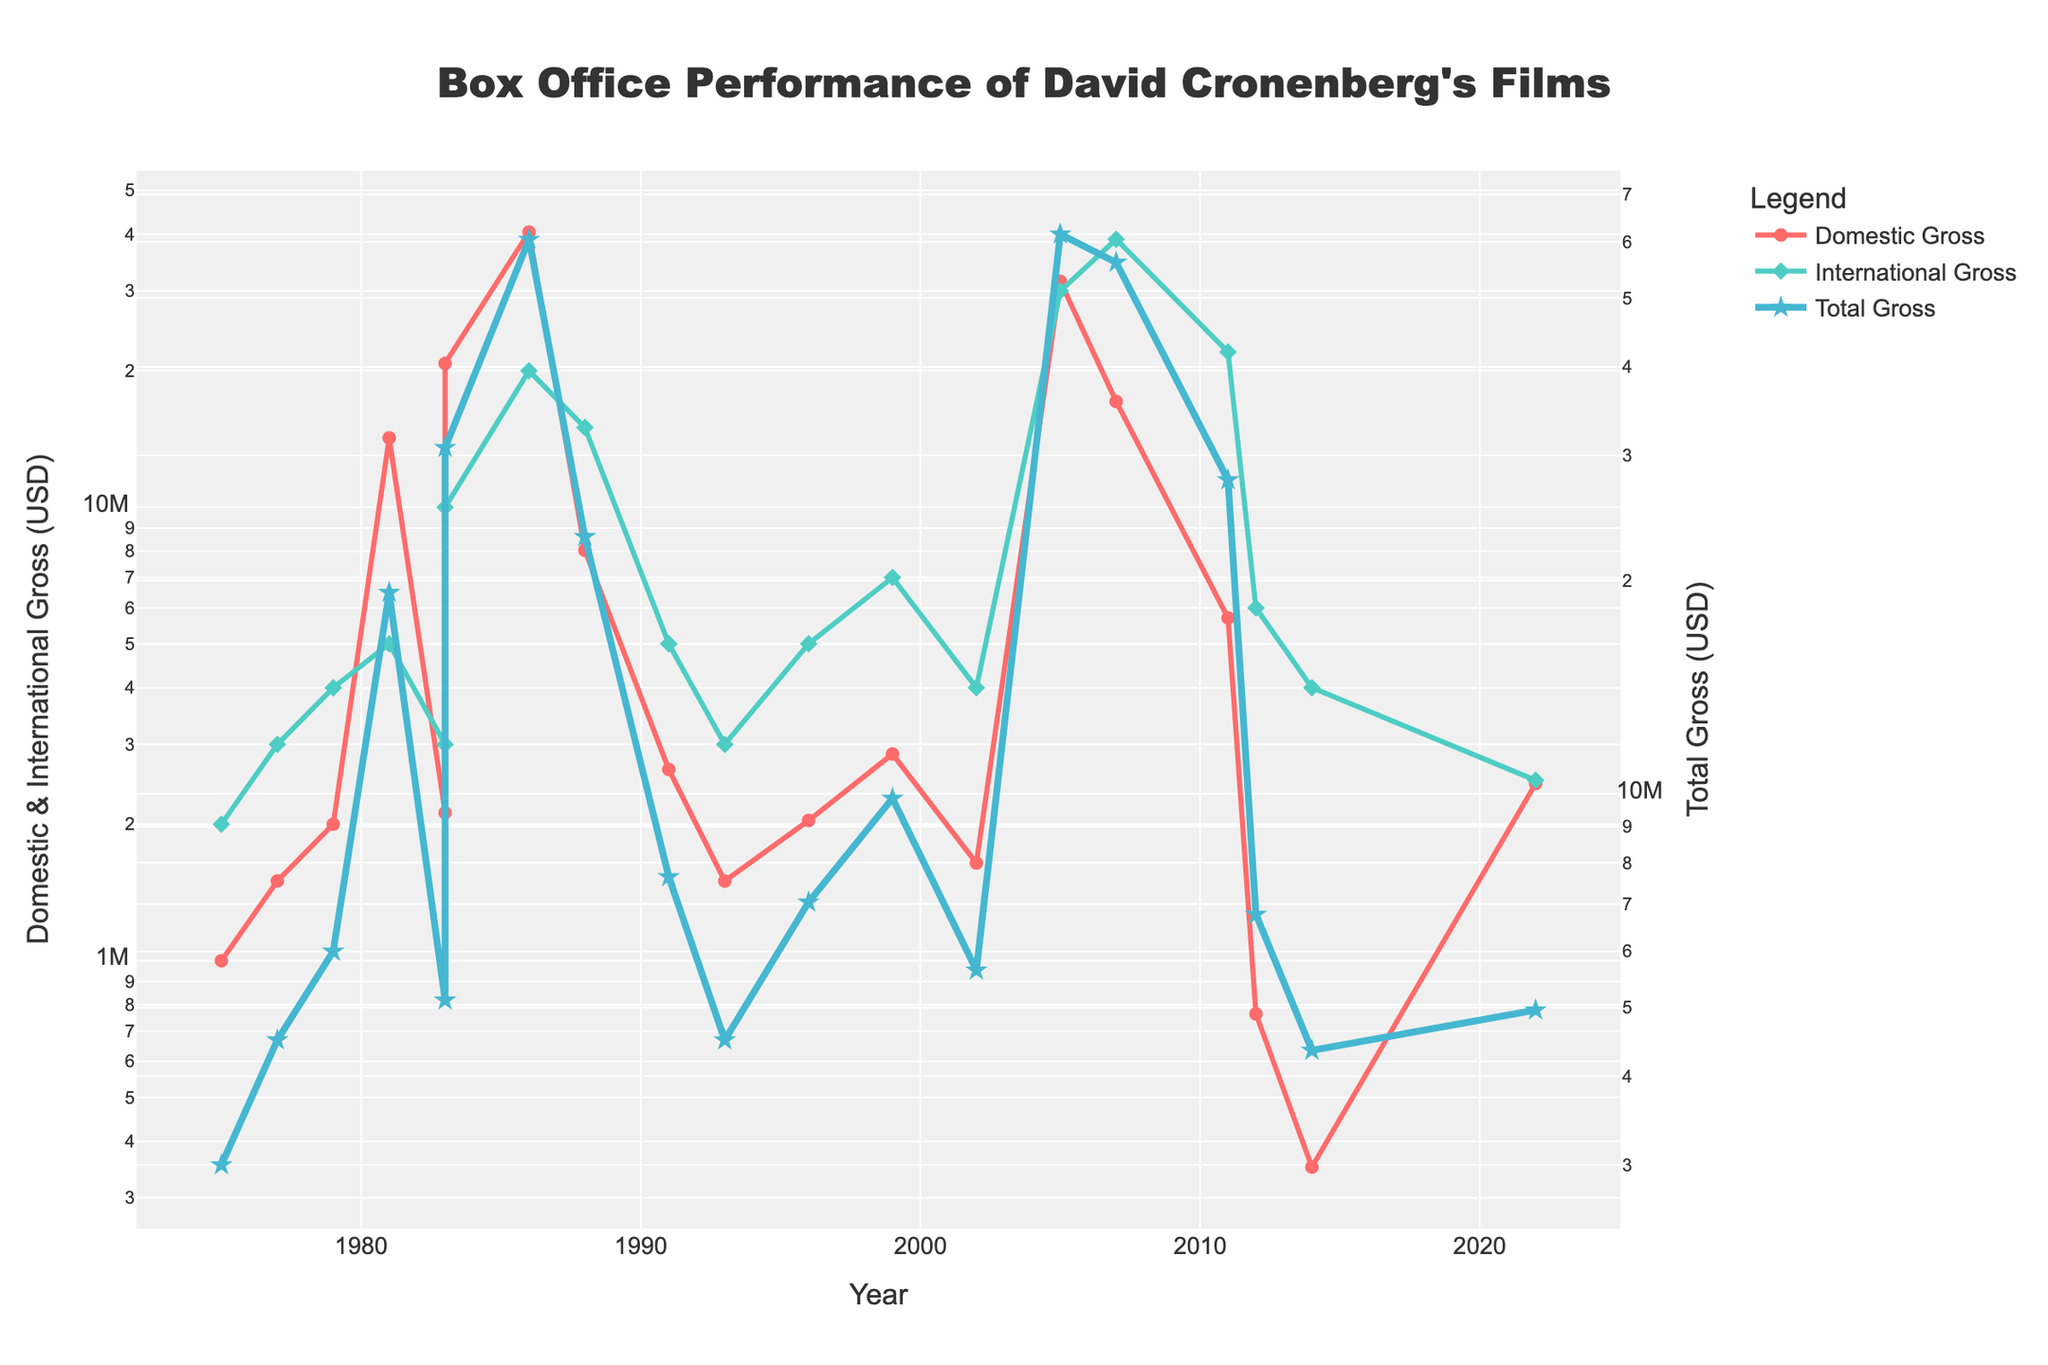What's the highest domestic gross achieved by Cronenberg's films? To find the highest domestic gross, look at the Domestic Gross line and identify the peak value. The highest point on this line corresponds to "The Fly" in 1986 with a gross indicated by the y-axis.
Answer: 40456565 Which film had a higher international gross: "A History of Violence" or "Eastern Promises"? Refer to the International Gross line and find the points corresponding to "A History of Violence" and "Eastern Promises". Compare their heights relative to the y-axis. "Eastern Promises" has a higher international gross of 39,000,000 USD compared to "A History of Violence" with 30,000,000 USD.
Answer: Eastern Promises What is the total gross difference between "Shivers" and "Crimes of the Future"? For each film, sum the domestic and international gross to find the total gross. "Shivers" has a total gross of 3,000,000 USD and "Crimes of the Future" has 4,758,481 USD. The difference is calculated as 4,758,481 - 3,000,000.
Answer: 1,758,481 Which film shows the lowest domestic gross and what is the value? Look for the lowest point on the Domestic Gross line. The lowest point corresponds to "Maps to the Stars" in 2014, with a domestic gross indicated by the y-axis.
Answer: 350741 How does the domestic gross trend compare between 1975 and 1986? Analyze the Domestic Gross trend line from 1975 to 1986. During this period, there is a general upward trend, with significant peaks occurring in the early 1980s and another peak at 1986 with "The Fly".
Answer: Upward trend What is the average international gross for Cronenberg's films in the 1990s? Identify the films released in the 1990s ("Naked Lunch," "M. Butterfly," "Crash," and "eXistenZ"). Sum their international gross values and divide by the number of films. (5,000,000 + 3,000,000 + 5,000,000 + 7,000,000) / 4 = 20,000,000 / 4.
Answer: 5,000,000 Determine the film with the highest total gross and state the value. The Total Gross line peaks at the highest point which corresponds to "A History of Violence" in 2005. The highest value shown is indicated by the y-axis for total gross.
Answer: 61,504,633 How many films released between 2000 and 2020 had a domestic gross over 5 million USD? Examine the films released between 2000 and 2020 and count those with a Domestic Gross above the 5 million mark. Films include "A History of Violence" (31,504,633) and "Eastern Promises" (17,114,882). Count these films.
Answer: 2 What is the ratio of international to domestic gross for "Videodrome"? Locate "Videodrome" and compare its international gross to its domestic gross. Divide the international gross (3,000,000) by the domestic gross (2,120,000) to find the ratio.
Answer: 1.42 Which period shows more fluctuation in total gross, 1975-1985 or 2000-2010? Compare the Total Gross line's variance in the two periods. From 1975-1985, the total gross values show significant changes, especially with highs and lows around "Scanners" to "Videodrome." Compare this with the steadier values in 2000-2010.
Answer: 1975-1985 